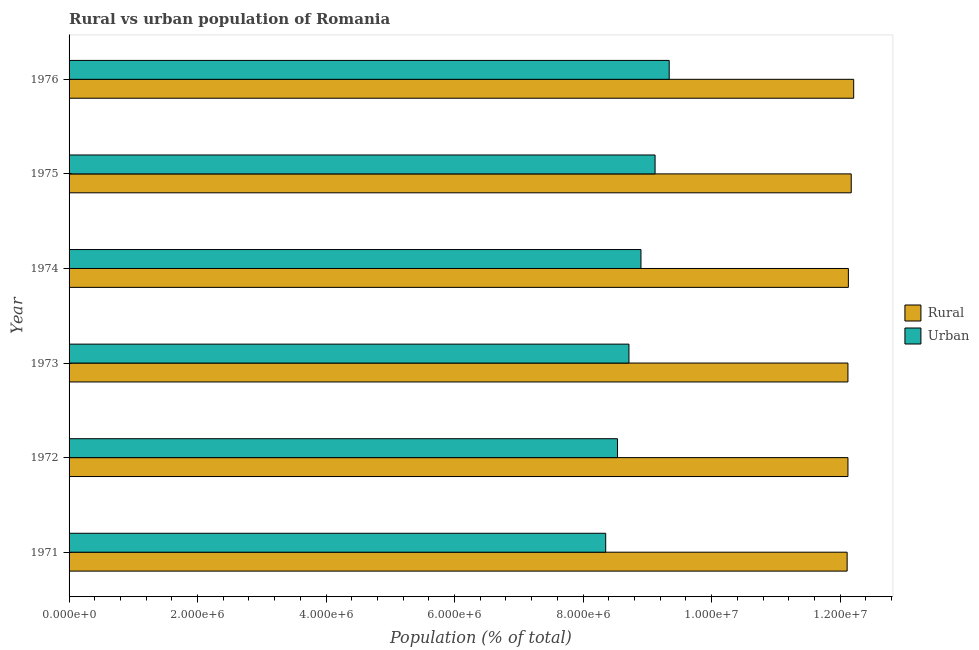How many groups of bars are there?
Give a very brief answer. 6. Are the number of bars per tick equal to the number of legend labels?
Give a very brief answer. Yes. Are the number of bars on each tick of the Y-axis equal?
Make the answer very short. Yes. How many bars are there on the 5th tick from the top?
Make the answer very short. 2. How many bars are there on the 6th tick from the bottom?
Your response must be concise. 2. What is the label of the 3rd group of bars from the top?
Offer a very short reply. 1974. What is the rural population density in 1972?
Your answer should be very brief. 1.21e+07. Across all years, what is the maximum rural population density?
Ensure brevity in your answer.  1.22e+07. Across all years, what is the minimum urban population density?
Ensure brevity in your answer.  8.35e+06. In which year was the urban population density maximum?
Offer a terse response. 1976. What is the total urban population density in the graph?
Ensure brevity in your answer.  5.30e+07. What is the difference between the rural population density in 1972 and that in 1974?
Make the answer very short. -6427. What is the difference between the urban population density in 1975 and the rural population density in 1976?
Provide a succinct answer. -3.09e+06. What is the average urban population density per year?
Your answer should be very brief. 8.83e+06. In the year 1973, what is the difference between the rural population density and urban population density?
Keep it short and to the point. 3.41e+06. What is the ratio of the urban population density in 1973 to that in 1976?
Offer a terse response. 0.93. Is the difference between the urban population density in 1973 and 1976 greater than the difference between the rural population density in 1973 and 1976?
Your response must be concise. No. What is the difference between the highest and the second highest rural population density?
Provide a succinct answer. 3.80e+04. What is the difference between the highest and the lowest urban population density?
Make the answer very short. 9.88e+05. What does the 1st bar from the top in 1974 represents?
Your answer should be compact. Urban. What does the 2nd bar from the bottom in 1975 represents?
Provide a short and direct response. Urban. What is the difference between two consecutive major ticks on the X-axis?
Provide a short and direct response. 2.00e+06. What is the title of the graph?
Keep it short and to the point. Rural vs urban population of Romania. Does "Rural" appear as one of the legend labels in the graph?
Provide a succinct answer. Yes. What is the label or title of the X-axis?
Your response must be concise. Population (% of total). What is the Population (% of total) in Rural in 1971?
Offer a very short reply. 1.21e+07. What is the Population (% of total) of Urban in 1971?
Provide a succinct answer. 8.35e+06. What is the Population (% of total) in Rural in 1972?
Ensure brevity in your answer.  1.21e+07. What is the Population (% of total) of Urban in 1972?
Give a very brief answer. 8.54e+06. What is the Population (% of total) of Rural in 1973?
Give a very brief answer. 1.21e+07. What is the Population (% of total) of Urban in 1973?
Keep it short and to the point. 8.71e+06. What is the Population (% of total) in Rural in 1974?
Provide a short and direct response. 1.21e+07. What is the Population (% of total) in Urban in 1974?
Ensure brevity in your answer.  8.90e+06. What is the Population (% of total) of Rural in 1975?
Keep it short and to the point. 1.22e+07. What is the Population (% of total) of Urban in 1975?
Give a very brief answer. 9.12e+06. What is the Population (% of total) of Rural in 1976?
Offer a very short reply. 1.22e+07. What is the Population (% of total) in Urban in 1976?
Your response must be concise. 9.34e+06. Across all years, what is the maximum Population (% of total) in Rural?
Give a very brief answer. 1.22e+07. Across all years, what is the maximum Population (% of total) in Urban?
Your response must be concise. 9.34e+06. Across all years, what is the minimum Population (% of total) in Rural?
Your response must be concise. 1.21e+07. Across all years, what is the minimum Population (% of total) in Urban?
Ensure brevity in your answer.  8.35e+06. What is the total Population (% of total) of Rural in the graph?
Make the answer very short. 7.29e+07. What is the total Population (% of total) of Urban in the graph?
Your answer should be compact. 5.30e+07. What is the difference between the Population (% of total) in Rural in 1971 and that in 1972?
Ensure brevity in your answer.  -1.27e+04. What is the difference between the Population (% of total) in Urban in 1971 and that in 1972?
Give a very brief answer. -1.84e+05. What is the difference between the Population (% of total) of Rural in 1971 and that in 1973?
Give a very brief answer. -1.24e+04. What is the difference between the Population (% of total) in Urban in 1971 and that in 1973?
Provide a succinct answer. -3.62e+05. What is the difference between the Population (% of total) of Rural in 1971 and that in 1974?
Your response must be concise. -1.92e+04. What is the difference between the Population (% of total) of Urban in 1971 and that in 1974?
Keep it short and to the point. -5.49e+05. What is the difference between the Population (% of total) in Rural in 1971 and that in 1975?
Give a very brief answer. -6.38e+04. What is the difference between the Population (% of total) in Urban in 1971 and that in 1975?
Make the answer very short. -7.68e+05. What is the difference between the Population (% of total) in Rural in 1971 and that in 1976?
Your answer should be compact. -1.02e+05. What is the difference between the Population (% of total) of Urban in 1971 and that in 1976?
Give a very brief answer. -9.88e+05. What is the difference between the Population (% of total) in Rural in 1972 and that in 1973?
Offer a very short reply. 305. What is the difference between the Population (% of total) in Urban in 1972 and that in 1973?
Your answer should be compact. -1.78e+05. What is the difference between the Population (% of total) of Rural in 1972 and that in 1974?
Provide a succinct answer. -6427. What is the difference between the Population (% of total) in Urban in 1972 and that in 1974?
Offer a very short reply. -3.65e+05. What is the difference between the Population (% of total) of Rural in 1972 and that in 1975?
Make the answer very short. -5.10e+04. What is the difference between the Population (% of total) of Urban in 1972 and that in 1975?
Keep it short and to the point. -5.85e+05. What is the difference between the Population (% of total) in Rural in 1972 and that in 1976?
Your response must be concise. -8.91e+04. What is the difference between the Population (% of total) of Urban in 1972 and that in 1976?
Your answer should be compact. -8.05e+05. What is the difference between the Population (% of total) of Rural in 1973 and that in 1974?
Keep it short and to the point. -6732. What is the difference between the Population (% of total) in Urban in 1973 and that in 1974?
Make the answer very short. -1.87e+05. What is the difference between the Population (% of total) in Rural in 1973 and that in 1975?
Make the answer very short. -5.13e+04. What is the difference between the Population (% of total) in Urban in 1973 and that in 1975?
Ensure brevity in your answer.  -4.07e+05. What is the difference between the Population (% of total) of Rural in 1973 and that in 1976?
Your answer should be very brief. -8.94e+04. What is the difference between the Population (% of total) of Urban in 1973 and that in 1976?
Your answer should be compact. -6.27e+05. What is the difference between the Population (% of total) in Rural in 1974 and that in 1975?
Keep it short and to the point. -4.46e+04. What is the difference between the Population (% of total) in Urban in 1974 and that in 1975?
Make the answer very short. -2.20e+05. What is the difference between the Population (% of total) in Rural in 1974 and that in 1976?
Offer a terse response. -8.26e+04. What is the difference between the Population (% of total) of Urban in 1974 and that in 1976?
Offer a very short reply. -4.40e+05. What is the difference between the Population (% of total) of Rural in 1975 and that in 1976?
Provide a short and direct response. -3.80e+04. What is the difference between the Population (% of total) of Urban in 1975 and that in 1976?
Give a very brief answer. -2.20e+05. What is the difference between the Population (% of total) of Rural in 1971 and the Population (% of total) of Urban in 1972?
Offer a very short reply. 3.57e+06. What is the difference between the Population (% of total) of Rural in 1971 and the Population (% of total) of Urban in 1973?
Ensure brevity in your answer.  3.40e+06. What is the difference between the Population (% of total) in Rural in 1971 and the Population (% of total) in Urban in 1974?
Ensure brevity in your answer.  3.21e+06. What is the difference between the Population (% of total) of Rural in 1971 and the Population (% of total) of Urban in 1975?
Your answer should be very brief. 2.99e+06. What is the difference between the Population (% of total) in Rural in 1971 and the Population (% of total) in Urban in 1976?
Offer a very short reply. 2.77e+06. What is the difference between the Population (% of total) of Rural in 1972 and the Population (% of total) of Urban in 1973?
Your response must be concise. 3.41e+06. What is the difference between the Population (% of total) in Rural in 1972 and the Population (% of total) in Urban in 1974?
Offer a very short reply. 3.22e+06. What is the difference between the Population (% of total) in Rural in 1972 and the Population (% of total) in Urban in 1975?
Make the answer very short. 3.00e+06. What is the difference between the Population (% of total) in Rural in 1972 and the Population (% of total) in Urban in 1976?
Your answer should be compact. 2.78e+06. What is the difference between the Population (% of total) of Rural in 1973 and the Population (% of total) of Urban in 1974?
Make the answer very short. 3.22e+06. What is the difference between the Population (% of total) in Rural in 1973 and the Population (% of total) in Urban in 1975?
Offer a very short reply. 3.00e+06. What is the difference between the Population (% of total) in Rural in 1973 and the Population (% of total) in Urban in 1976?
Provide a short and direct response. 2.78e+06. What is the difference between the Population (% of total) in Rural in 1974 and the Population (% of total) in Urban in 1975?
Offer a very short reply. 3.01e+06. What is the difference between the Population (% of total) in Rural in 1974 and the Population (% of total) in Urban in 1976?
Provide a short and direct response. 2.79e+06. What is the difference between the Population (% of total) of Rural in 1975 and the Population (% of total) of Urban in 1976?
Your response must be concise. 2.83e+06. What is the average Population (% of total) in Rural per year?
Provide a succinct answer. 1.21e+07. What is the average Population (% of total) in Urban per year?
Offer a terse response. 8.83e+06. In the year 1971, what is the difference between the Population (% of total) in Rural and Population (% of total) in Urban?
Provide a short and direct response. 3.76e+06. In the year 1972, what is the difference between the Population (% of total) in Rural and Population (% of total) in Urban?
Give a very brief answer. 3.59e+06. In the year 1973, what is the difference between the Population (% of total) in Rural and Population (% of total) in Urban?
Ensure brevity in your answer.  3.41e+06. In the year 1974, what is the difference between the Population (% of total) of Rural and Population (% of total) of Urban?
Give a very brief answer. 3.23e+06. In the year 1975, what is the difference between the Population (% of total) of Rural and Population (% of total) of Urban?
Your answer should be very brief. 3.05e+06. In the year 1976, what is the difference between the Population (% of total) in Rural and Population (% of total) in Urban?
Make the answer very short. 2.87e+06. What is the ratio of the Population (% of total) in Urban in 1971 to that in 1972?
Offer a terse response. 0.98. What is the ratio of the Population (% of total) in Rural in 1971 to that in 1973?
Give a very brief answer. 1. What is the ratio of the Population (% of total) in Urban in 1971 to that in 1973?
Your response must be concise. 0.96. What is the ratio of the Population (% of total) in Rural in 1971 to that in 1974?
Keep it short and to the point. 1. What is the ratio of the Population (% of total) in Urban in 1971 to that in 1974?
Your answer should be compact. 0.94. What is the ratio of the Population (% of total) in Rural in 1971 to that in 1975?
Keep it short and to the point. 0.99. What is the ratio of the Population (% of total) of Urban in 1971 to that in 1975?
Provide a short and direct response. 0.92. What is the ratio of the Population (% of total) of Urban in 1971 to that in 1976?
Keep it short and to the point. 0.89. What is the ratio of the Population (% of total) of Urban in 1972 to that in 1973?
Give a very brief answer. 0.98. What is the ratio of the Population (% of total) of Rural in 1972 to that in 1975?
Provide a short and direct response. 1. What is the ratio of the Population (% of total) in Urban in 1972 to that in 1975?
Ensure brevity in your answer.  0.94. What is the ratio of the Population (% of total) in Rural in 1972 to that in 1976?
Your answer should be very brief. 0.99. What is the ratio of the Population (% of total) of Urban in 1972 to that in 1976?
Make the answer very short. 0.91. What is the ratio of the Population (% of total) in Rural in 1973 to that in 1974?
Offer a terse response. 1. What is the ratio of the Population (% of total) in Urban in 1973 to that in 1974?
Provide a short and direct response. 0.98. What is the ratio of the Population (% of total) of Rural in 1973 to that in 1975?
Offer a very short reply. 1. What is the ratio of the Population (% of total) in Urban in 1973 to that in 1975?
Make the answer very short. 0.96. What is the ratio of the Population (% of total) in Rural in 1973 to that in 1976?
Keep it short and to the point. 0.99. What is the ratio of the Population (% of total) of Urban in 1973 to that in 1976?
Make the answer very short. 0.93. What is the ratio of the Population (% of total) in Rural in 1974 to that in 1975?
Your response must be concise. 1. What is the ratio of the Population (% of total) in Urban in 1974 to that in 1975?
Your response must be concise. 0.98. What is the ratio of the Population (% of total) in Rural in 1974 to that in 1976?
Offer a terse response. 0.99. What is the ratio of the Population (% of total) in Urban in 1974 to that in 1976?
Offer a terse response. 0.95. What is the ratio of the Population (% of total) in Urban in 1975 to that in 1976?
Your answer should be compact. 0.98. What is the difference between the highest and the second highest Population (% of total) of Rural?
Offer a terse response. 3.80e+04. What is the difference between the highest and the second highest Population (% of total) of Urban?
Ensure brevity in your answer.  2.20e+05. What is the difference between the highest and the lowest Population (% of total) in Rural?
Keep it short and to the point. 1.02e+05. What is the difference between the highest and the lowest Population (% of total) in Urban?
Your answer should be compact. 9.88e+05. 